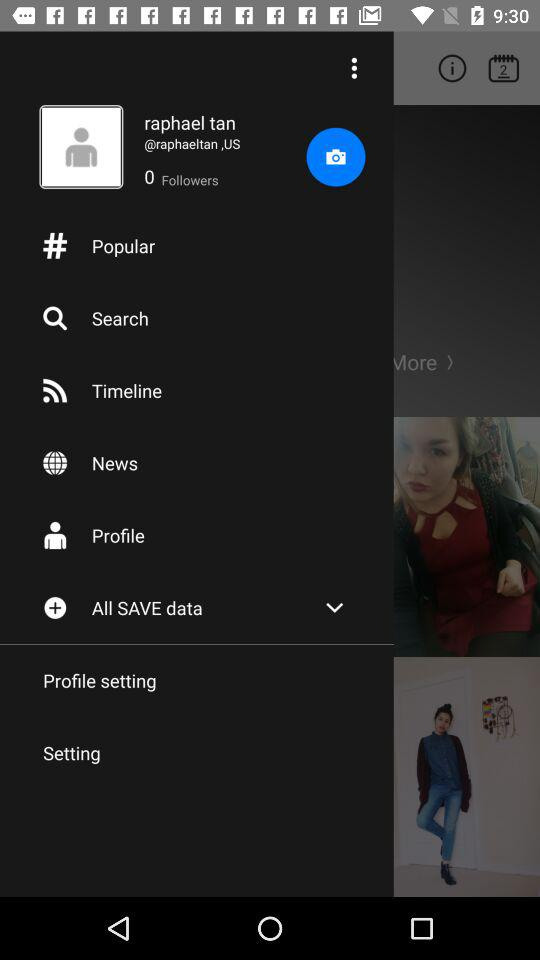What is the name? The name is Raphael Tan. 